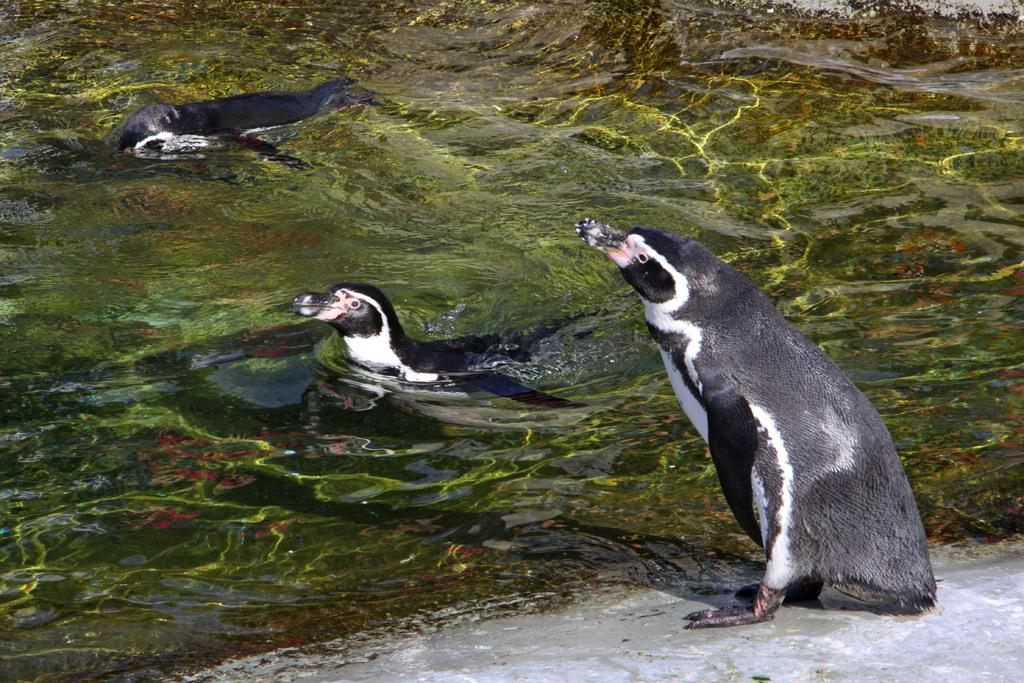What type of animals can be seen in the water in the image? There are snakes and penguins in the water. Can you describe the environment in which the animals are located? The animals are in the water. What effect does the school have on the cloud in the image? There is no school or cloud present in the image, so it is not possible to determine any effect. 